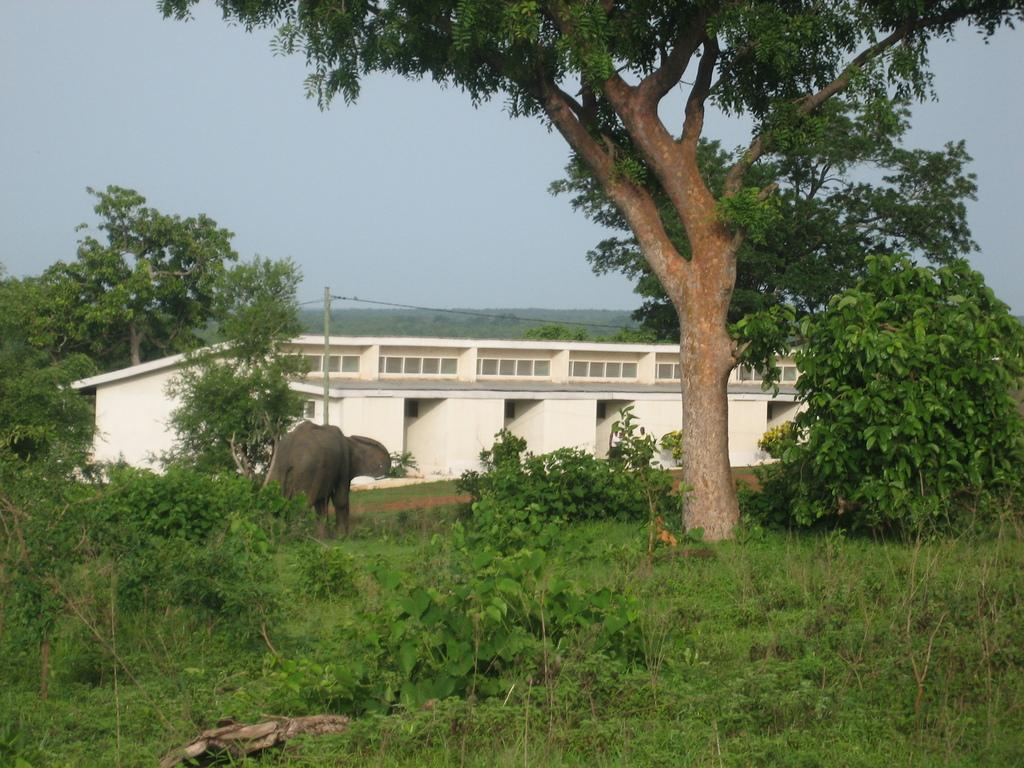What type of structure can be seen in the image? There is a building in the image. What else can be seen in the image besides the building? There is an electrical pole with wires, trees, plants, grass, and an elephant visible in the image. What is the natural environment like in the image? The natural environment includes trees, plants, grass, and the sky visible in the background. How many sheep are grazing in the grass in the image? There are no sheep present in the image. Can you describe the cat sitting on the electrical pole in the image? There is no cat present in the image; it only features an elephant. 